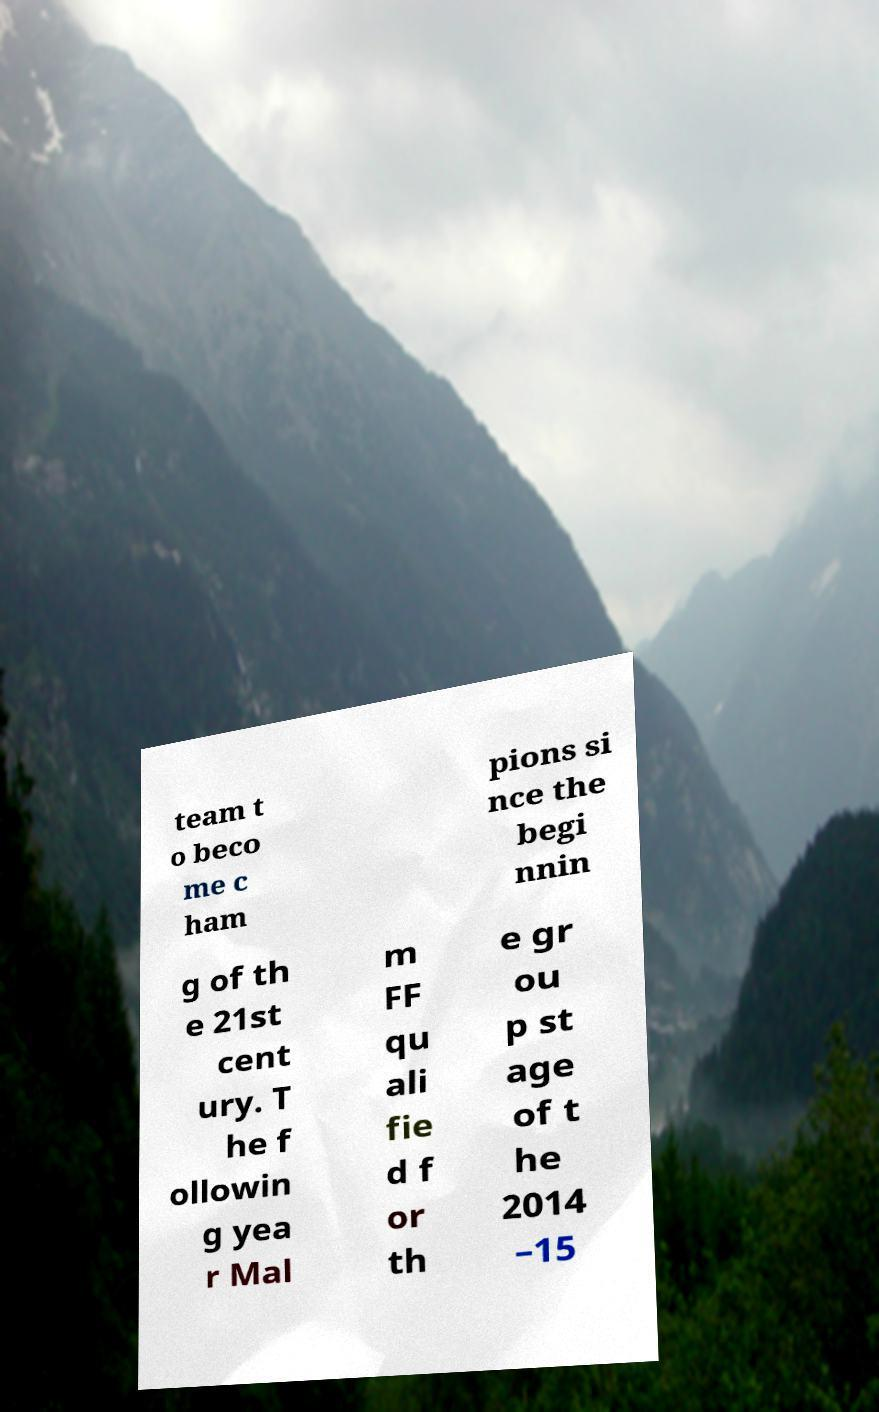Could you assist in decoding the text presented in this image and type it out clearly? team t o beco me c ham pions si nce the begi nnin g of th e 21st cent ury. T he f ollowin g yea r Mal m FF qu ali fie d f or th e gr ou p st age of t he 2014 –15 